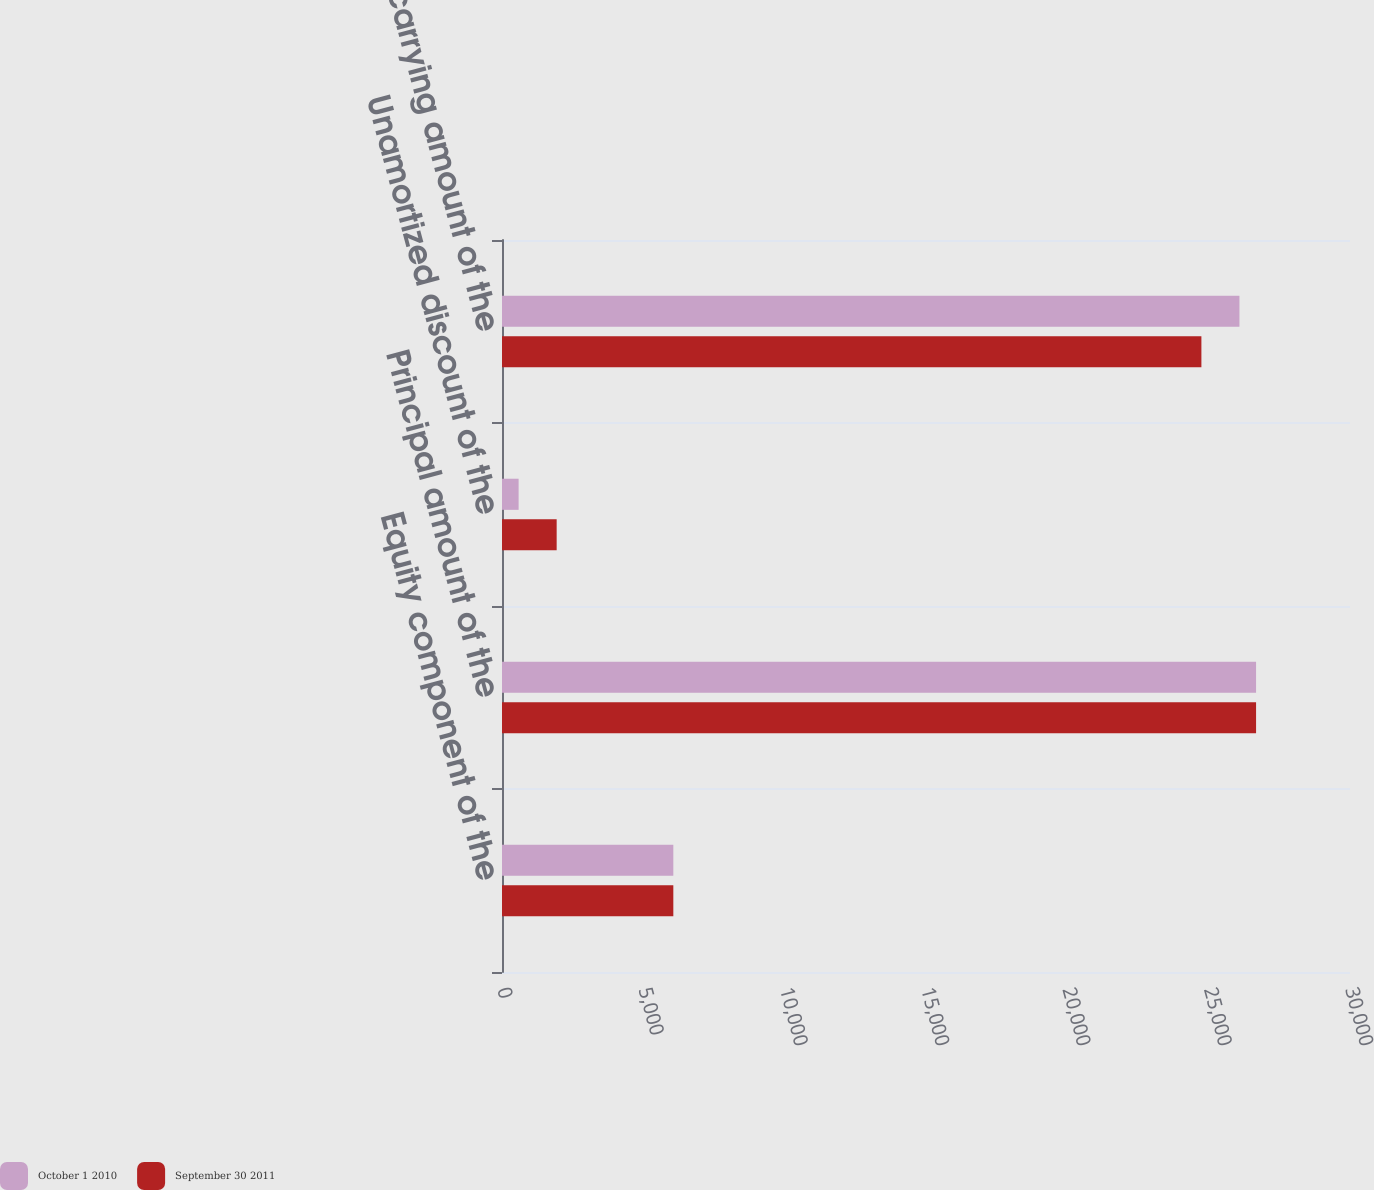Convert chart. <chart><loc_0><loc_0><loc_500><loc_500><stacked_bar_chart><ecel><fcel>Equity component of the<fcel>Principal amount of the<fcel>Unamortized discount of the<fcel>Net carrying amount of the<nl><fcel>October 1 2010<fcel>6061<fcel>26677<fcel>588<fcel>26089<nl><fcel>September 30 2011<fcel>6061<fcel>26677<fcel>1934<fcel>24743<nl></chart> 